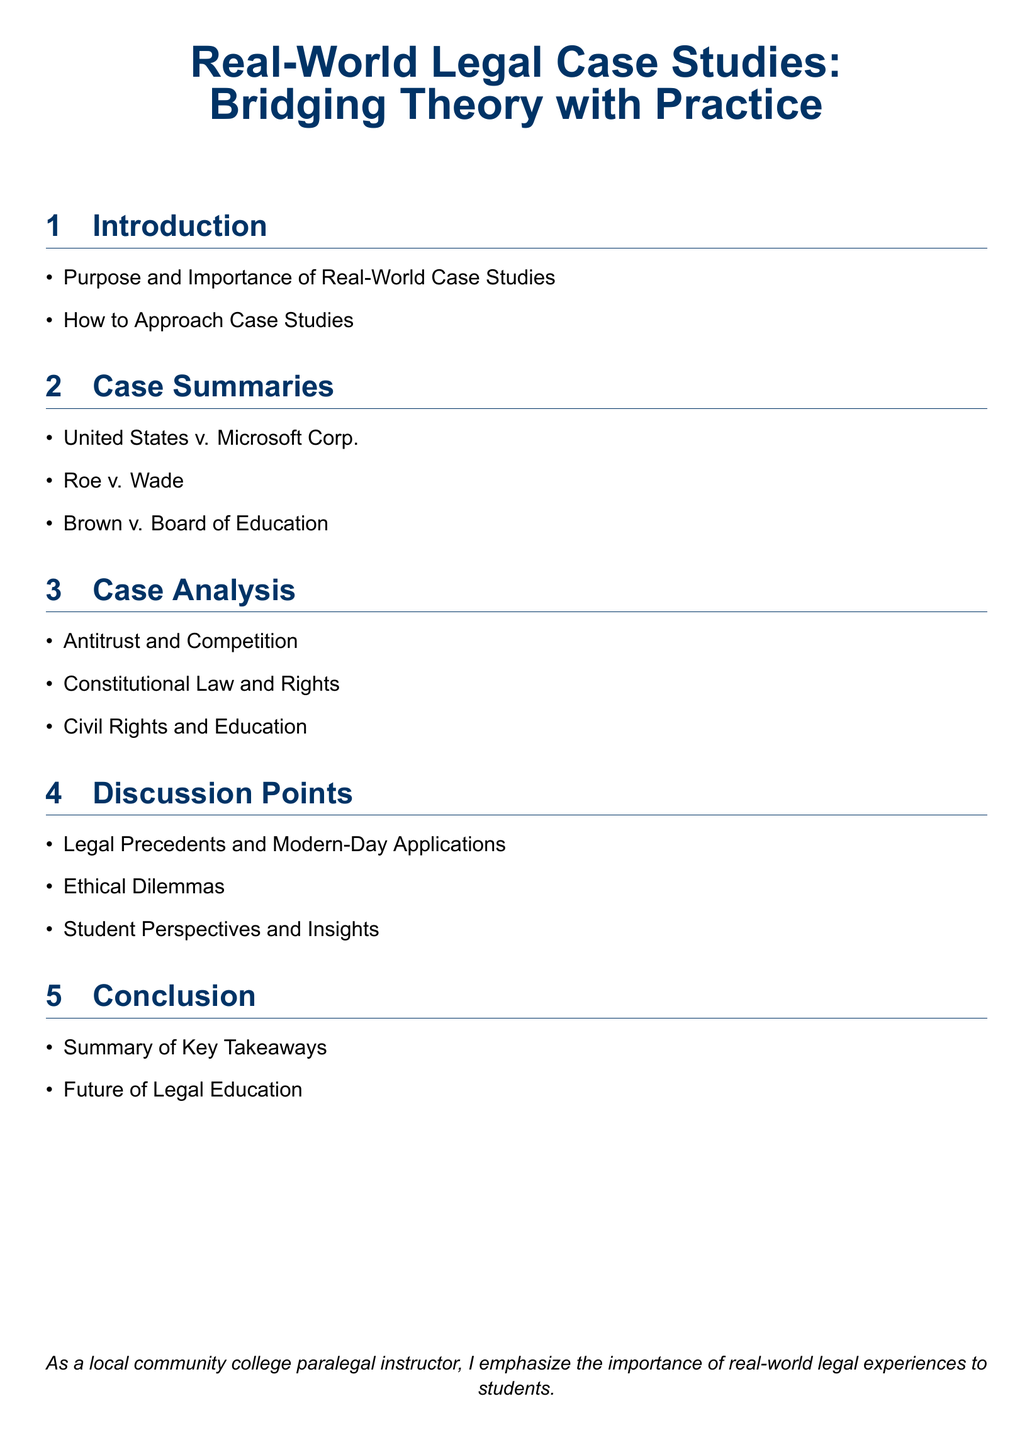What is the title of the document? The title of the document is mentioned at the beginning and summarizes the content.
Answer: Real-World Legal Case Studies: Bridging Theory with Practice How many major sections are there in the document? The document has five main sections indicated in the table of contents.
Answer: 5 What is the first case summary listed? The first case summary is listed in the "Case Summaries" section of the document.
Answer: United States v. Microsoft Corp What legal topic is analyzed in the second subsection? The "Case Analysis" section lists topics that focus on legal principles and issues.
Answer: Constitutional Law and Rights What is one discussion point mentioned in the document? The document includes a section on discussion points that emphasizes relevant legal conversations.
Answer: Ethical Dilemmas What is emphasized in the conclusion section? The conclusion summarizes key points of learning and perspectives offered in the document.
Answer: Summary of Key Takeaways 